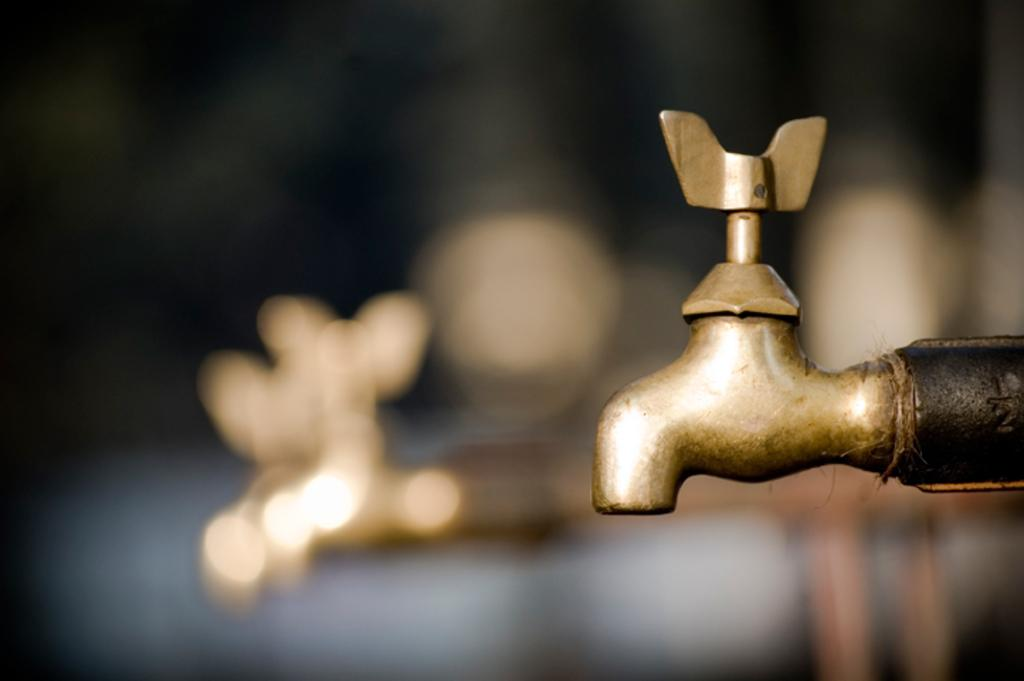What object can be seen in the image? There is a tap in the image. Can you describe the background of the image? The background of the image is blurred. What type of bushes can be seen growing near the tap in the image? There are no bushes visible in the image; only the tap and the blurred background are present. Is the tap located in a country setting in the image? The image does not provide enough information to determine the setting or location of the tap. Can you see any oil leaking from the tap in the image? There is no indication of oil or any leaks in the image; only the tap and the blurred background are present. 